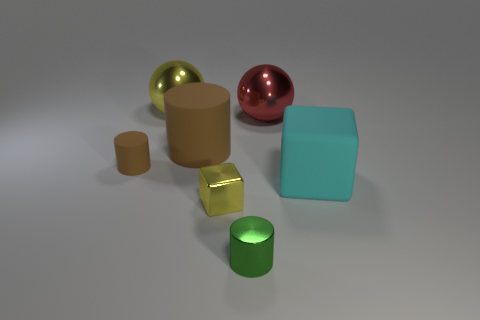Is there anything else that is made of the same material as the cyan object?
Your response must be concise. Yes. Is the color of the big matte cylinder the same as the tiny matte cylinder?
Give a very brief answer. Yes. The metallic ball that is on the right side of the big metal thing on the left side of the small shiny object that is on the left side of the green object is what color?
Your response must be concise. Red. Do the cyan object and the big cylinder have the same material?
Provide a short and direct response. Yes. There is a tiny green cylinder; what number of large spheres are in front of it?
Make the answer very short. 0. The other shiny thing that is the same shape as the large red object is what size?
Make the answer very short. Large. What number of green things are blocks or matte balls?
Ensure brevity in your answer.  0. How many cylinders are in front of the block that is to the left of the large matte cube?
Make the answer very short. 1. How many other objects are the same shape as the red thing?
Offer a terse response. 1. What material is the big sphere that is the same color as the small block?
Your response must be concise. Metal. 